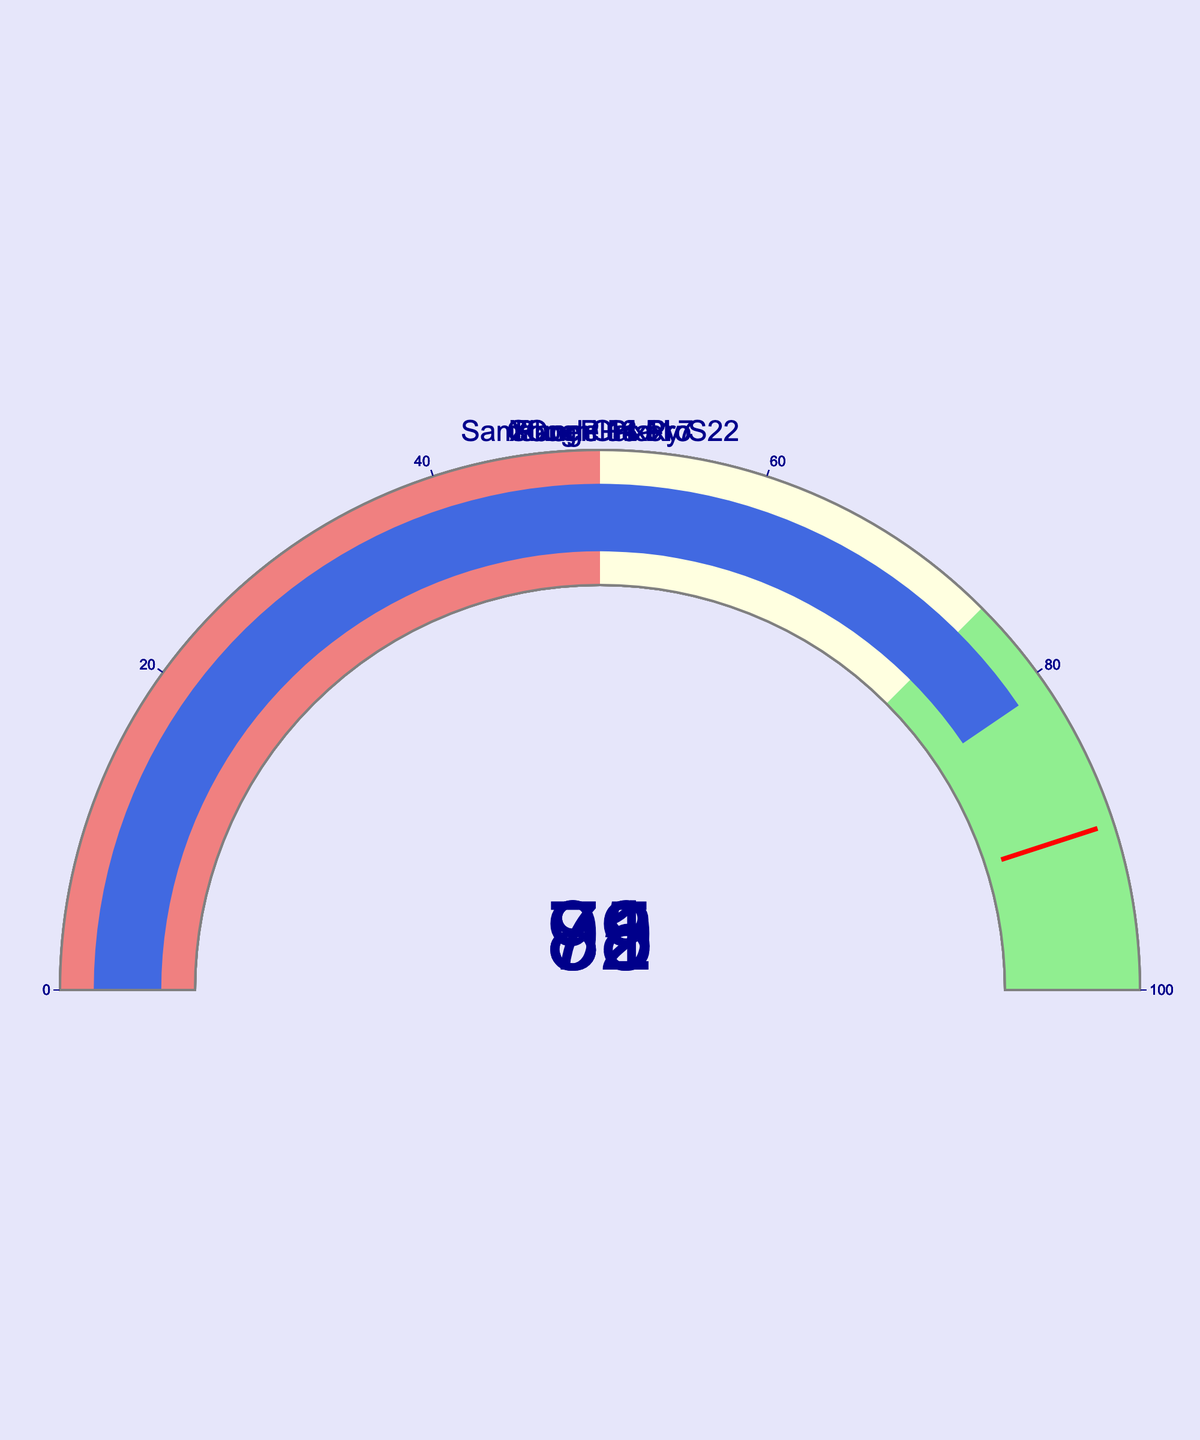What is the battery life of the iPhone 14 Pro? Locate the gauge labeled "iPhone 14 Pro" and read the displayed numeric value.
Answer: 92 Which device has the highest battery life? Compare all the numeric values displayed on the gauges to identify the highest value.
Answer: iPhone 14 Pro What is the median battery life of all the devices? The battery life values are 92, 78, 85, 89, and 81. Arranging them in order: 78, 81, 85, 89, 92. The median value is the middle number in this ordered list.
Answer: 85 How many devices have a battery life less than 80? Count the gauges displaying values less than 80.
Answer: 1 What is the difference between the battery life of the Samsung Galaxy S22 and the Google Pixel 7? Subtract the battery life of the Google Pixel 7 (78) from that of the Samsung Galaxy S22 (85).
Answer: 7 Which devices fall within the light green range (75-100)? Identify the gauges with values between 75 and 100, inclusive.
Answer: iPhone 14 Pro, Google Pixel 7, Samsung Galaxy S22, OnePlus 11, Xiaomi 13 Pro How many devices have a battery life greater than 85? Count the gauges displaying values greater than 85.
Answer: 2 What is the average battery life of all the devices? Sum the battery life values (92 + 78 + 85 + 89 + 81) to get 425. Divide this by the number of devices (5).
Answer: 85 